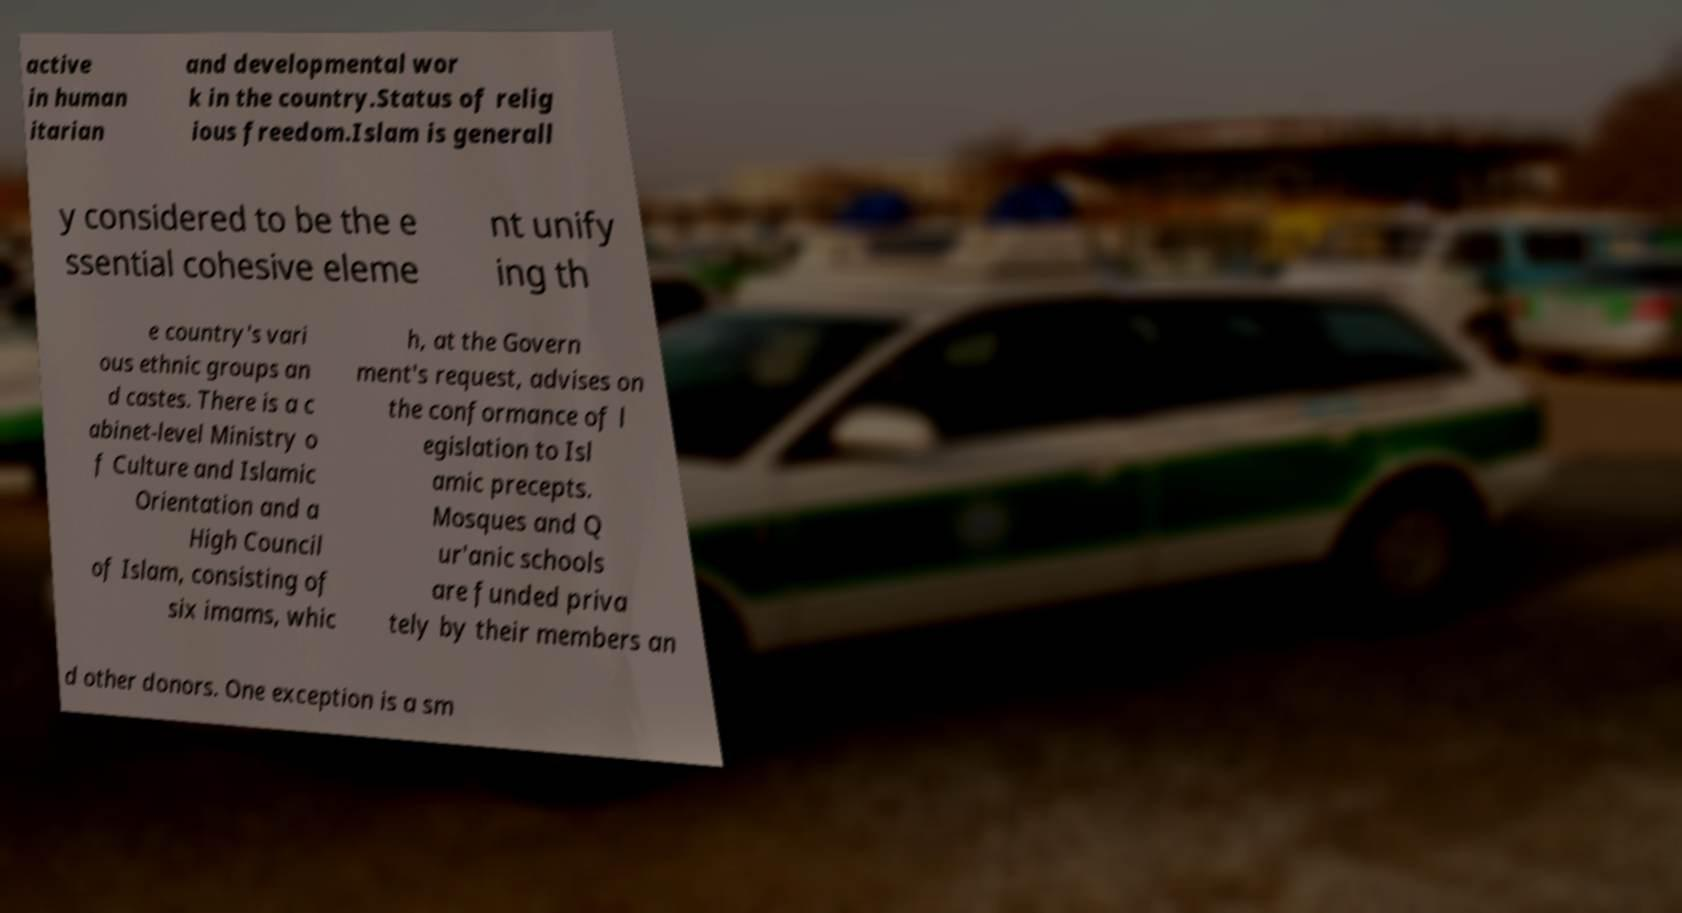Please read and relay the text visible in this image. What does it say? active in human itarian and developmental wor k in the country.Status of relig ious freedom.Islam is generall y considered to be the e ssential cohesive eleme nt unify ing th e country's vari ous ethnic groups an d castes. There is a c abinet-level Ministry o f Culture and Islamic Orientation and a High Council of Islam, consisting of six imams, whic h, at the Govern ment's request, advises on the conformance of l egislation to Isl amic precepts. Mosques and Q ur'anic schools are funded priva tely by their members an d other donors. One exception is a sm 